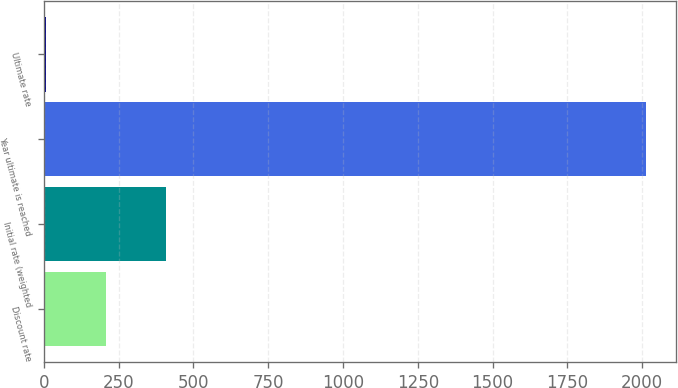Convert chart. <chart><loc_0><loc_0><loc_500><loc_500><bar_chart><fcel>Discount rate<fcel>Initial rate (weighted<fcel>Year ultimate is reached<fcel>Ultimate rate<nl><fcel>206.15<fcel>406.8<fcel>2012<fcel>5.5<nl></chart> 